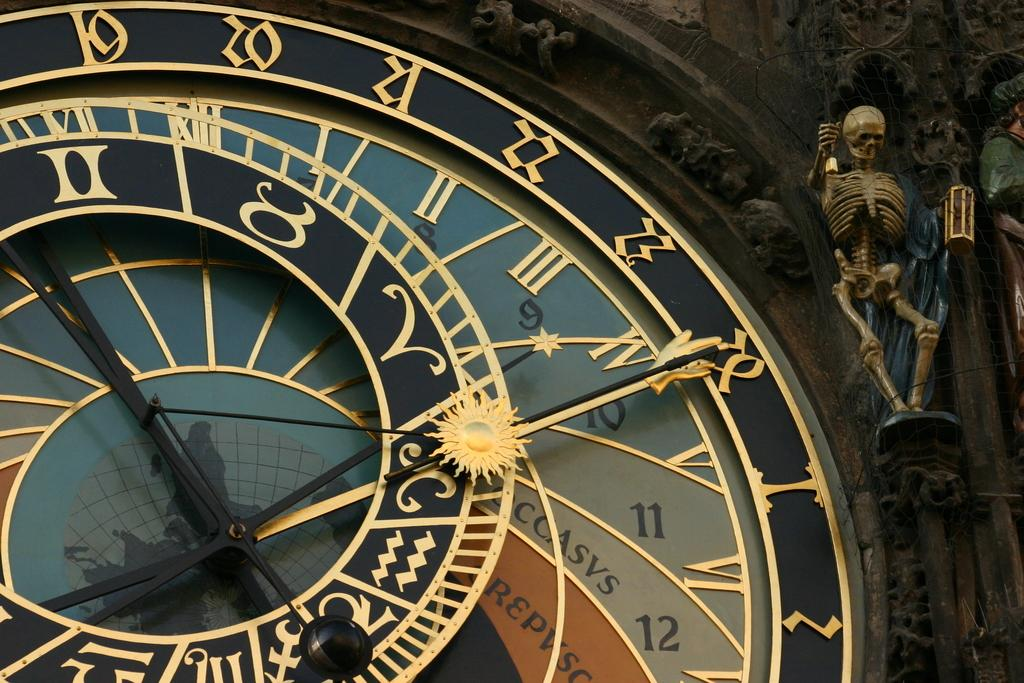<image>
Share a concise interpretation of the image provided. The bottom most number on the middle ring of the clock is 12 